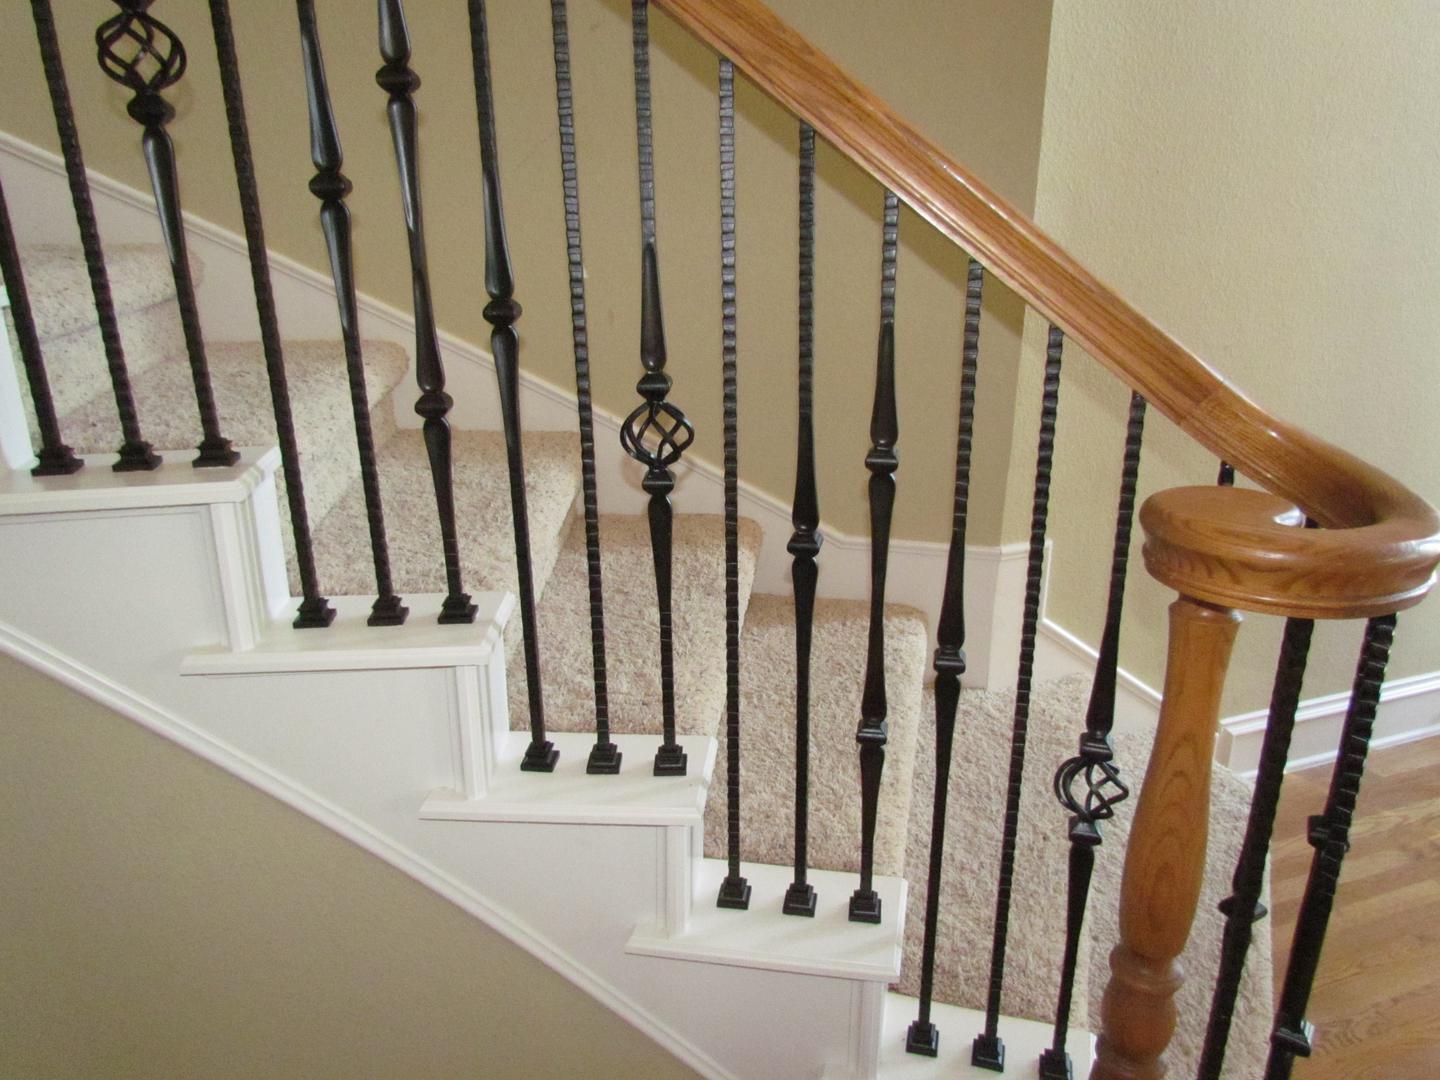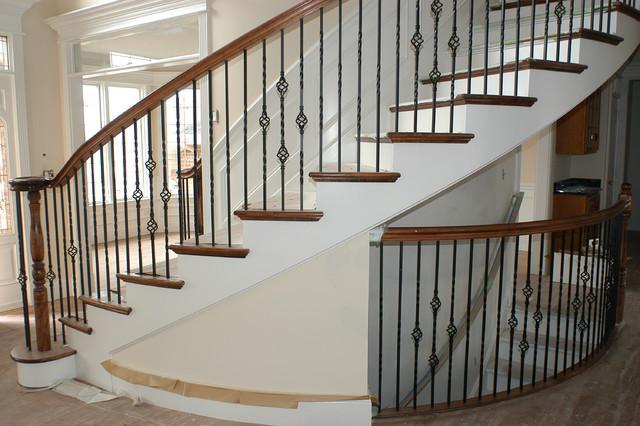The first image is the image on the left, the second image is the image on the right. Evaluate the accuracy of this statement regarding the images: "Two staircases and bannisters curve as they go downstairs.". Is it true? Answer yes or no. Yes. The first image is the image on the left, the second image is the image on the right. Evaluate the accuracy of this statement regarding the images: "there is a wood rail staircase with black iron rods and carpeted stairs". Is it true? Answer yes or no. Yes. 